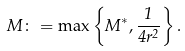<formula> <loc_0><loc_0><loc_500><loc_500>M \colon = \max \left \{ M ^ { * } , \frac { 1 } { 4 r ^ { 2 } } \right \} .</formula> 